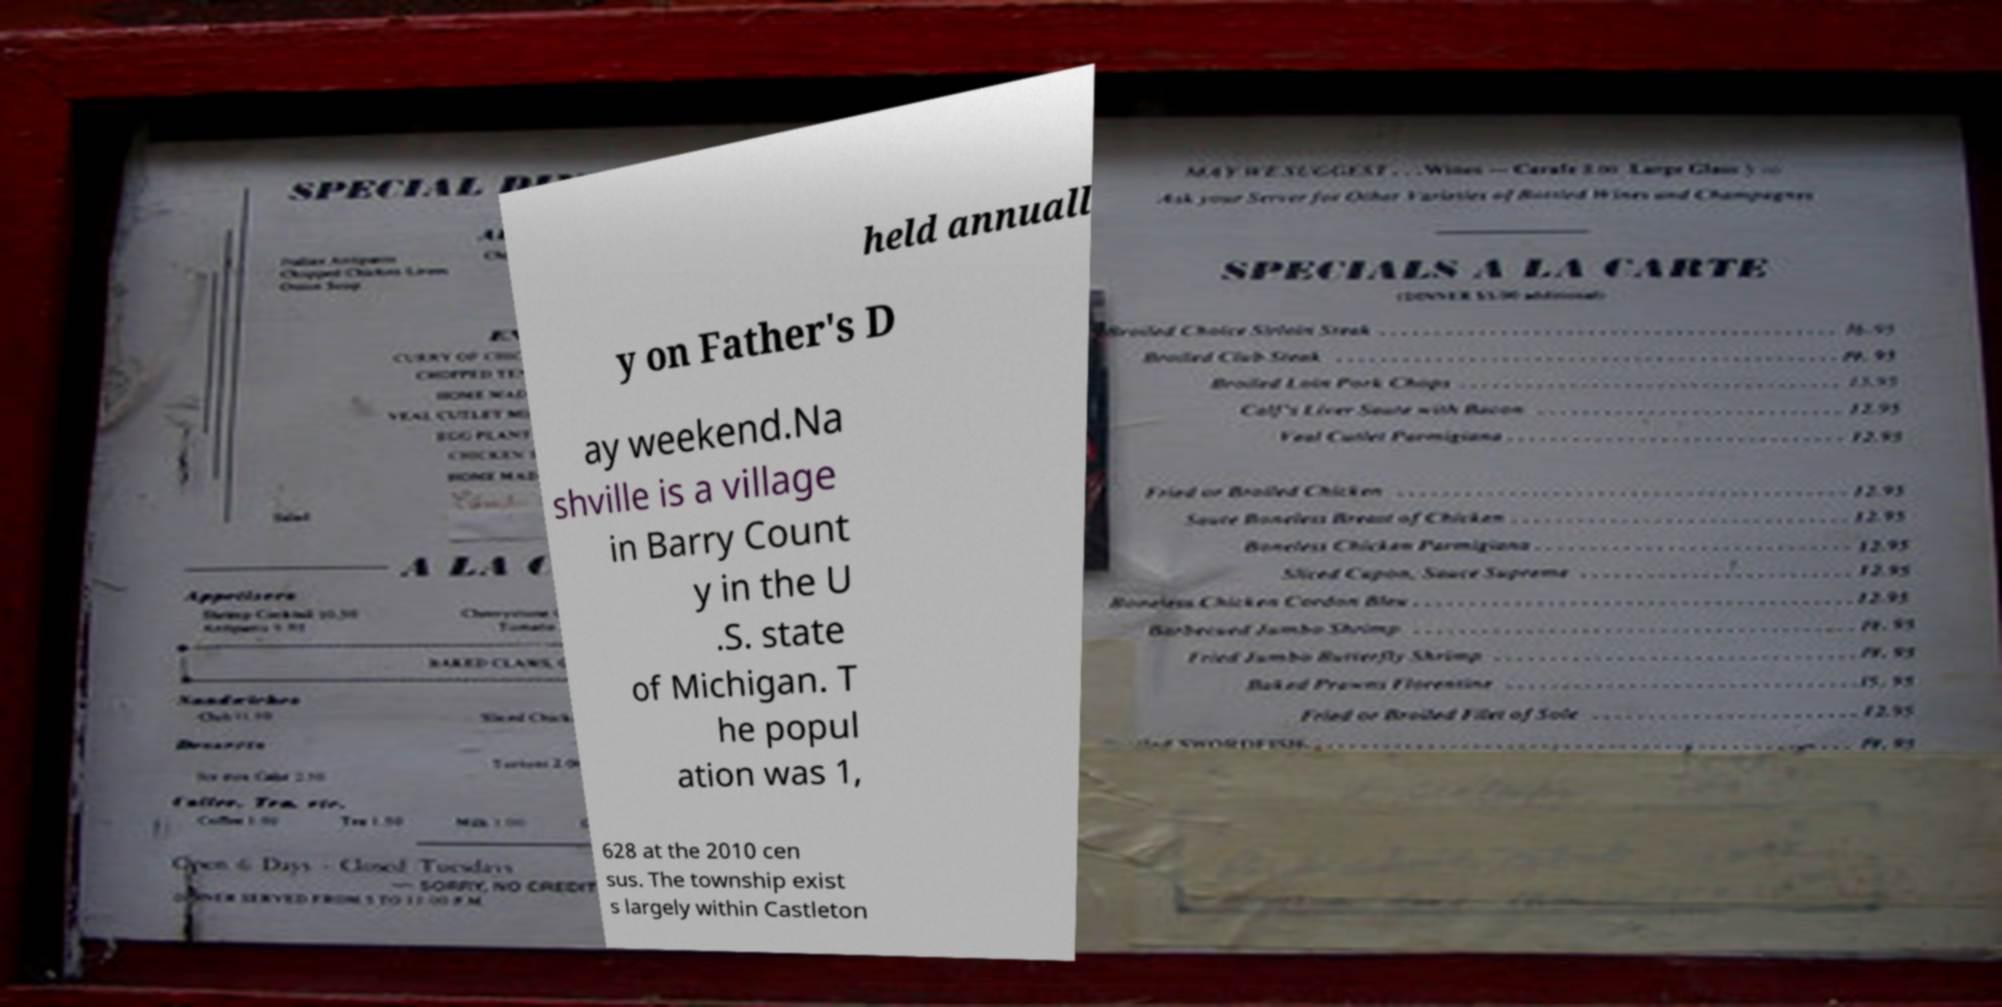Could you assist in decoding the text presented in this image and type it out clearly? held annuall y on Father's D ay weekend.Na shville is a village in Barry Count y in the U .S. state of Michigan. T he popul ation was 1, 628 at the 2010 cen sus. The township exist s largely within Castleton 